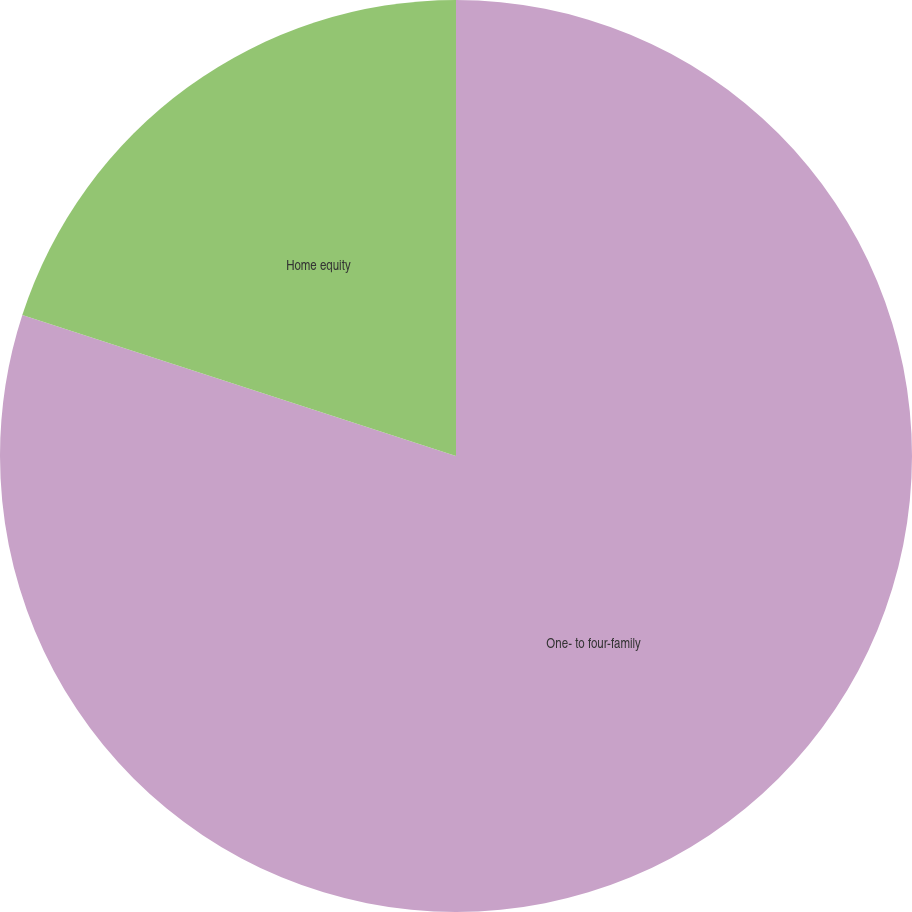<chart> <loc_0><loc_0><loc_500><loc_500><pie_chart><fcel>One- to four-family<fcel>Home equity<nl><fcel>80.0%<fcel>20.0%<nl></chart> 